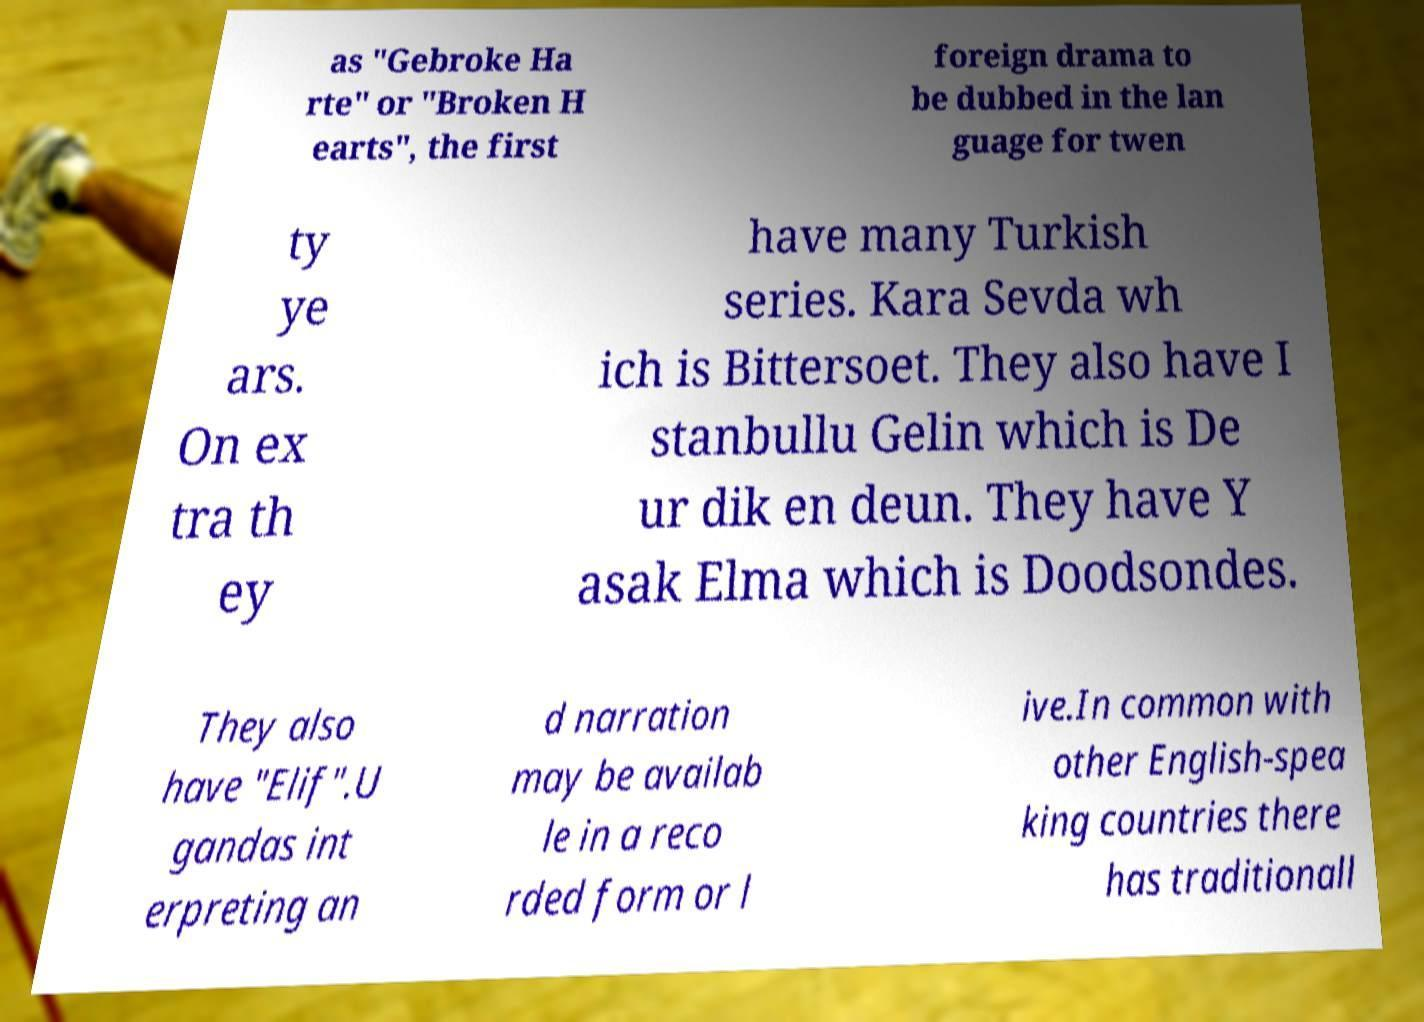For documentation purposes, I need the text within this image transcribed. Could you provide that? as "Gebroke Ha rte" or "Broken H earts", the first foreign drama to be dubbed in the lan guage for twen ty ye ars. On ex tra th ey have many Turkish series. Kara Sevda wh ich is Bittersoet. They also have I stanbullu Gelin which is De ur dik en deun. They have Y asak Elma which is Doodsondes. They also have "Elif".U gandas int erpreting an d narration may be availab le in a reco rded form or l ive.In common with other English-spea king countries there has traditionall 